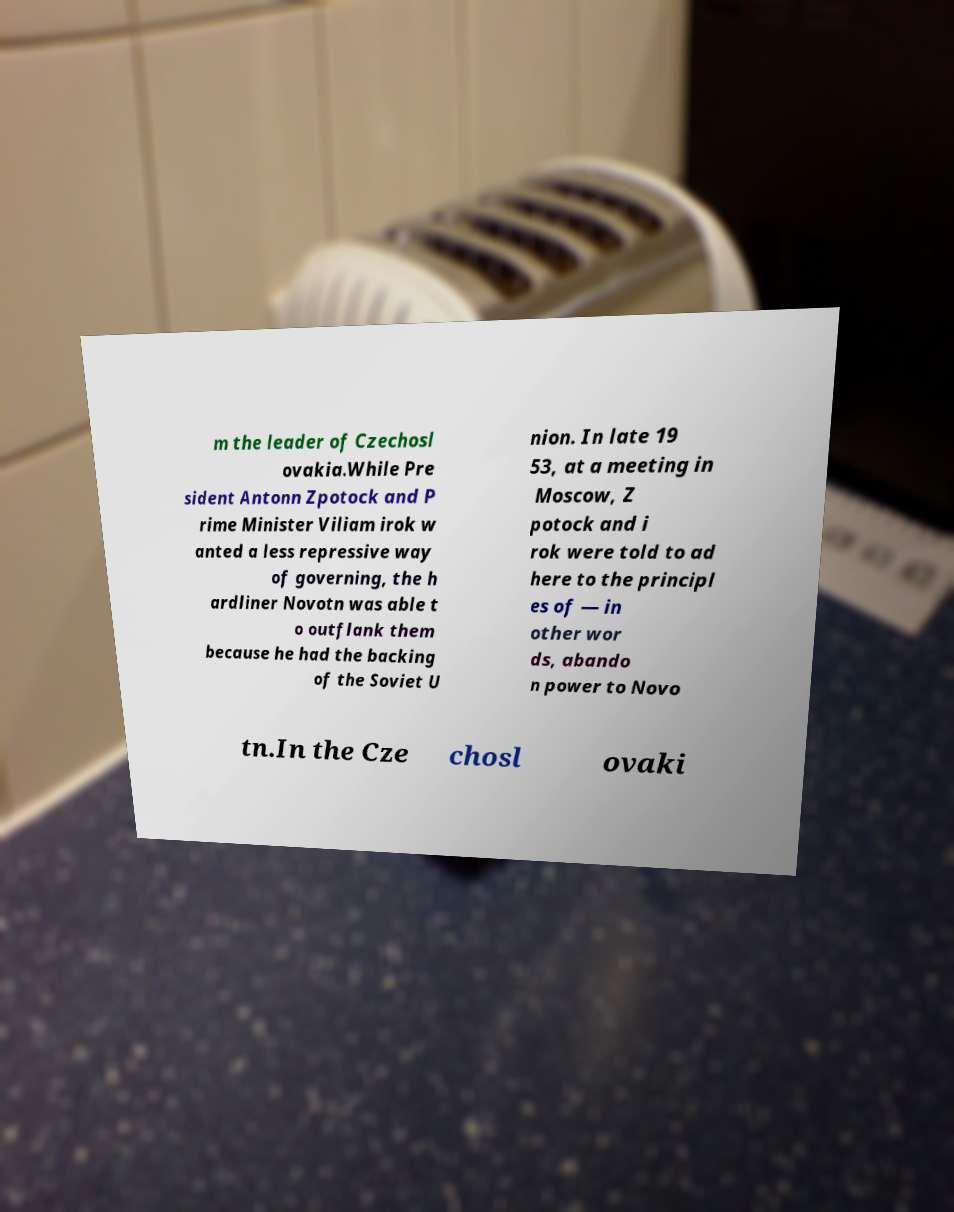For documentation purposes, I need the text within this image transcribed. Could you provide that? m the leader of Czechosl ovakia.While Pre sident Antonn Zpotock and P rime Minister Viliam irok w anted a less repressive way of governing, the h ardliner Novotn was able t o outflank them because he had the backing of the Soviet U nion. In late 19 53, at a meeting in Moscow, Z potock and i rok were told to ad here to the principl es of — in other wor ds, abando n power to Novo tn.In the Cze chosl ovaki 